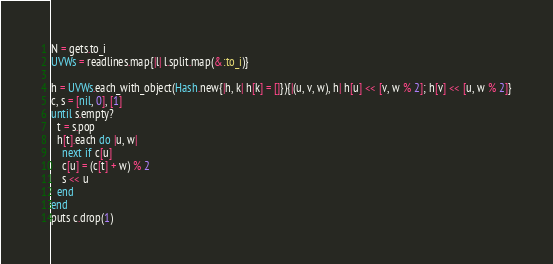Convert code to text. <code><loc_0><loc_0><loc_500><loc_500><_Ruby_>N = gets.to_i
UVWs = readlines.map{|l| l.split.map(&:to_i)}

h = UVWs.each_with_object(Hash.new{|h, k| h[k] = []}){|(u, v, w), h| h[u] << [v, w % 2]; h[v] << [u, w % 2]}
c, s = [nil, 0], [1]
until s.empty?
  t = s.pop
  h[t].each do |u, w|
    next if c[u]
    c[u] = (c[t] + w) % 2
    s << u
  end
end
puts c.drop(1)</code> 